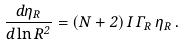<formula> <loc_0><loc_0><loc_500><loc_500>\frac { d \eta _ { R } } { d \ln R ^ { 2 } } = ( N + 2 ) \, I \, \Gamma _ { R } \, \eta _ { R } \, .</formula> 